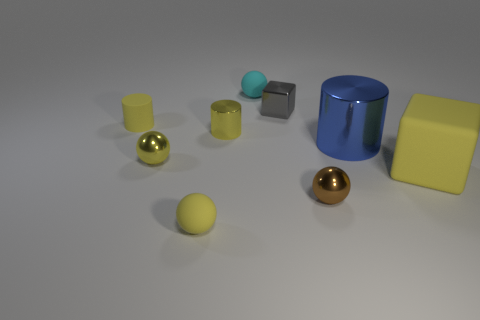Subtract all blue spheres. Subtract all green cylinders. How many spheres are left? 4 Subtract all balls. How many objects are left? 5 Subtract all small brown shiny spheres. Subtract all big brown metal cylinders. How many objects are left? 8 Add 4 large blocks. How many large blocks are left? 5 Add 8 red rubber cubes. How many red rubber cubes exist? 8 Subtract 0 cyan cylinders. How many objects are left? 9 